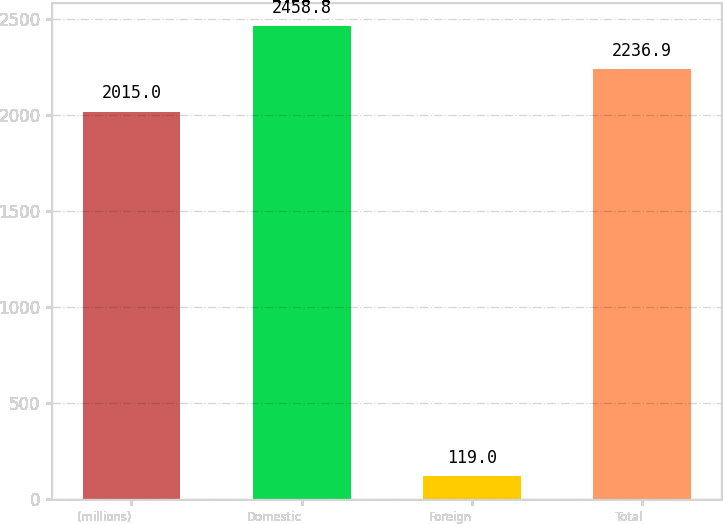<chart> <loc_0><loc_0><loc_500><loc_500><bar_chart><fcel>(millions)<fcel>Domestic<fcel>Foreign<fcel>Total<nl><fcel>2015<fcel>2458.8<fcel>119<fcel>2236.9<nl></chart> 